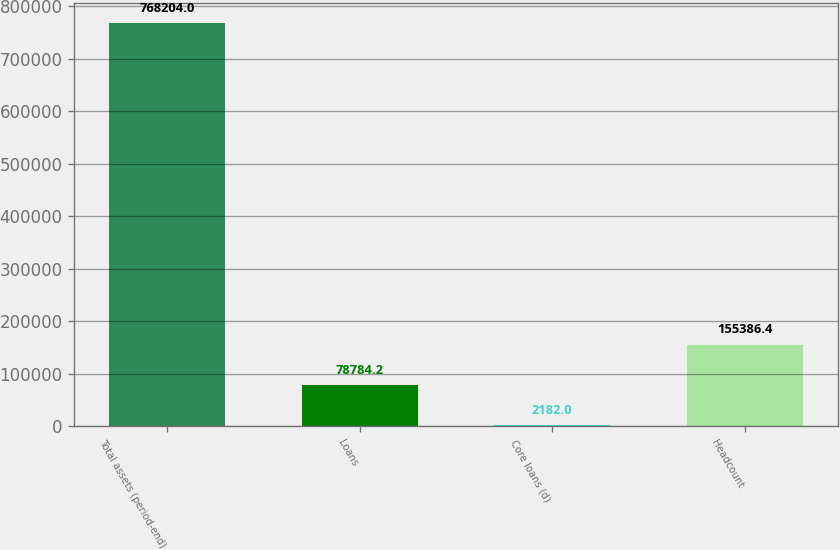Convert chart. <chart><loc_0><loc_0><loc_500><loc_500><bar_chart><fcel>Total assets (period-end)<fcel>Loans<fcel>Core loans (d)<fcel>Headcount<nl><fcel>768204<fcel>78784.2<fcel>2182<fcel>155386<nl></chart> 